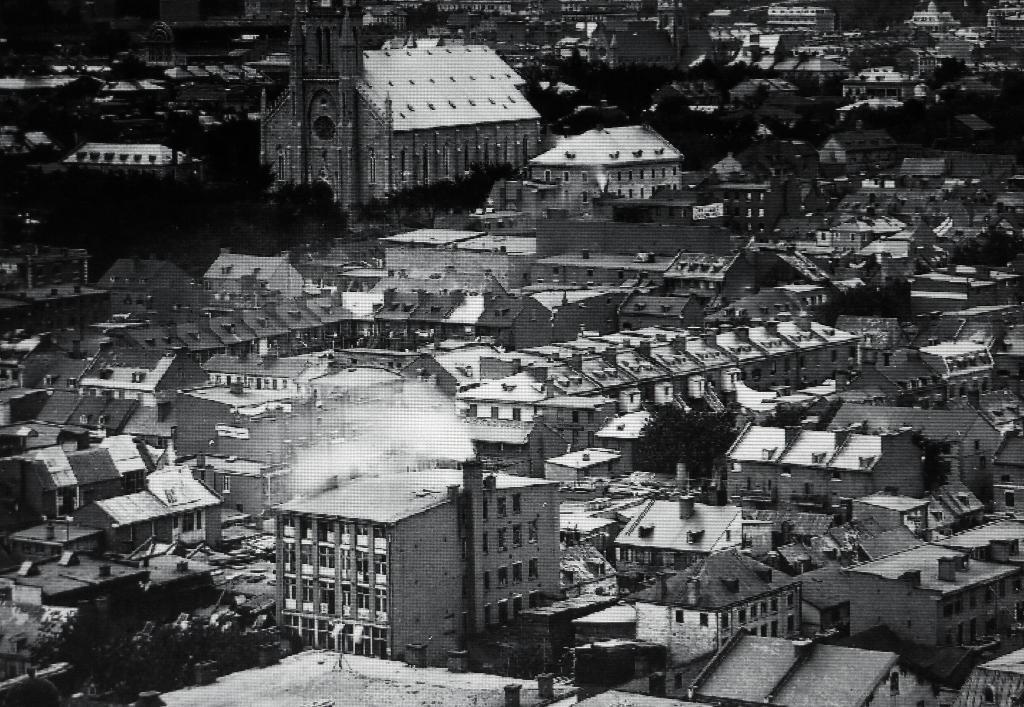Can you describe this image briefly? In this image we can see black and white picture of a group of buildings with windows and roofs and some trees. 